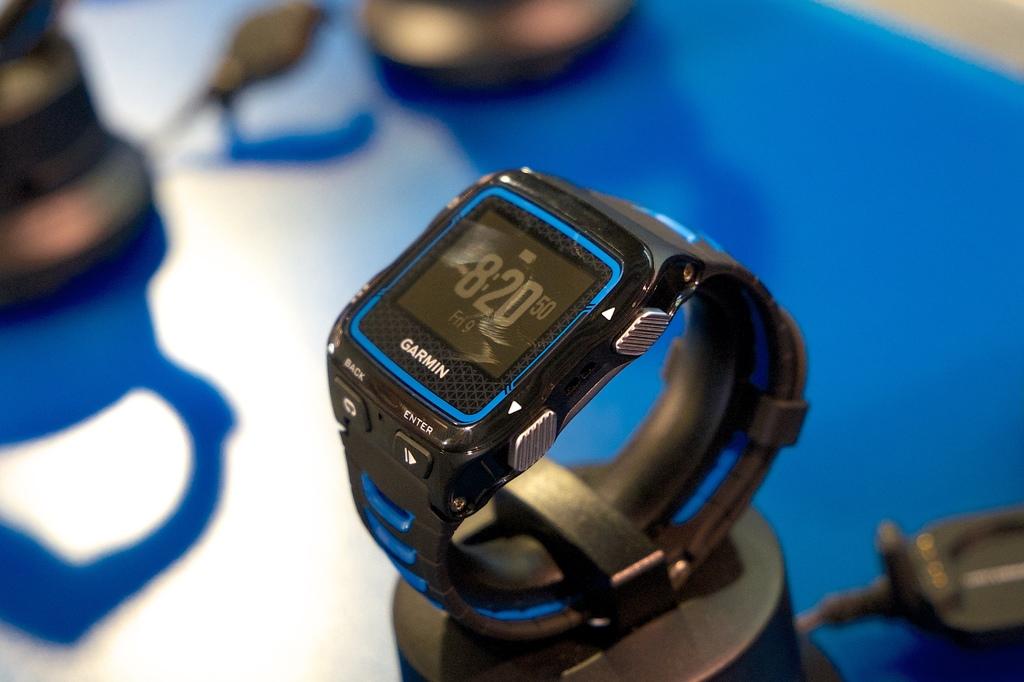What number is on the digital screen?
Keep it short and to the point. 8:20. What brand of watch is this?
Your answer should be very brief. Garmin. 